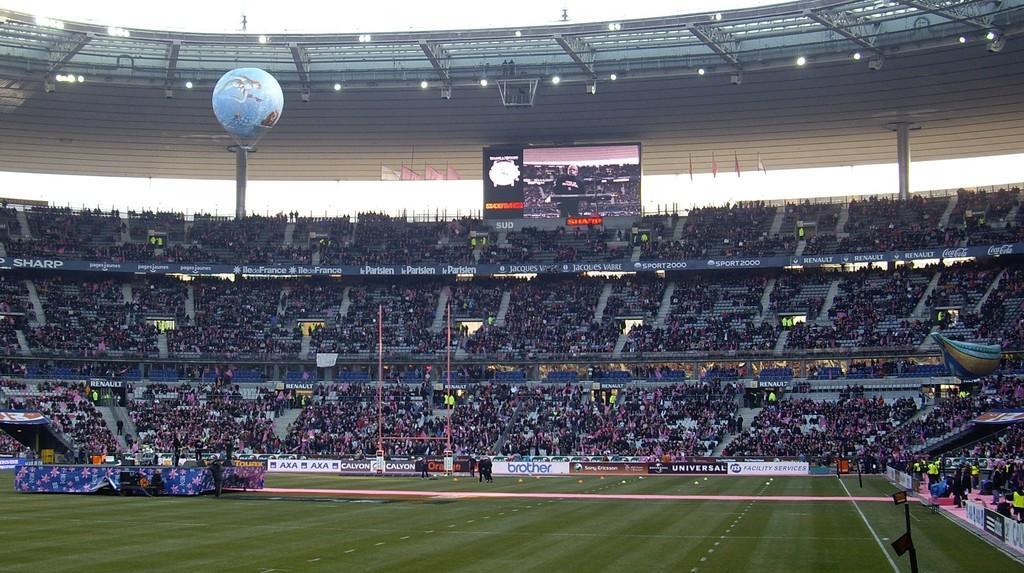Please provide a concise description of this image. In this image we can see ground, hoardings, poles, cloth, chairs, screen, people, parachute, lights, pillars, roof, flags, steps, and other objects. In the background there is sky. 